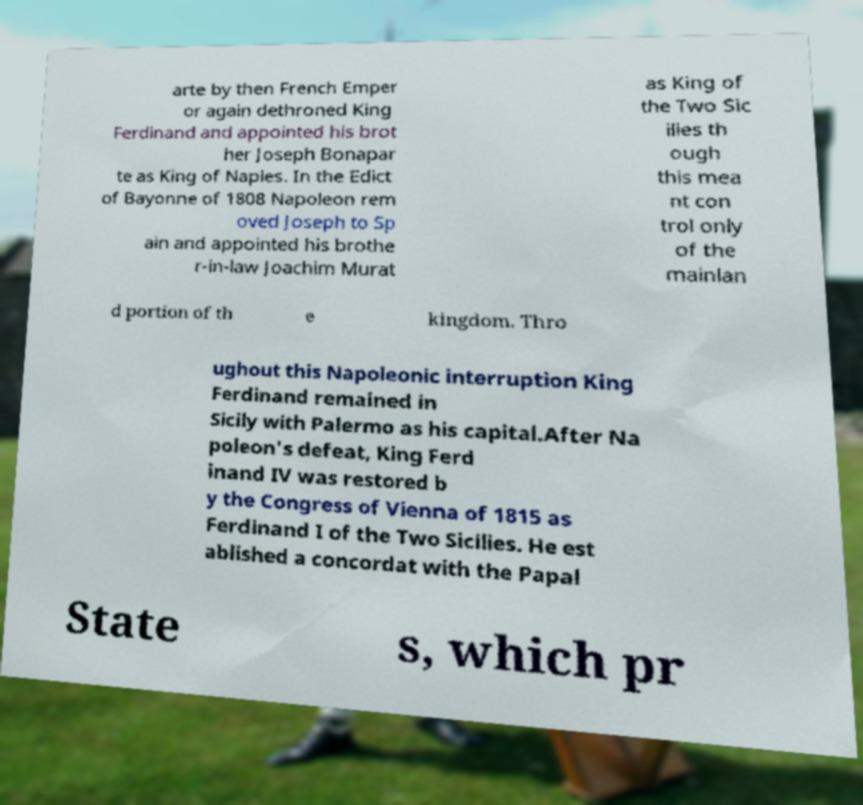There's text embedded in this image that I need extracted. Can you transcribe it verbatim? arte by then French Emper or again dethroned King Ferdinand and appointed his brot her Joseph Bonapar te as King of Naples. In the Edict of Bayonne of 1808 Napoleon rem oved Joseph to Sp ain and appointed his brothe r-in-law Joachim Murat as King of the Two Sic ilies th ough this mea nt con trol only of the mainlan d portion of th e kingdom. Thro ughout this Napoleonic interruption King Ferdinand remained in Sicily with Palermo as his capital.After Na poleon's defeat, King Ferd inand IV was restored b y the Congress of Vienna of 1815 as Ferdinand I of the Two Sicilies. He est ablished a concordat with the Papal State s, which pr 